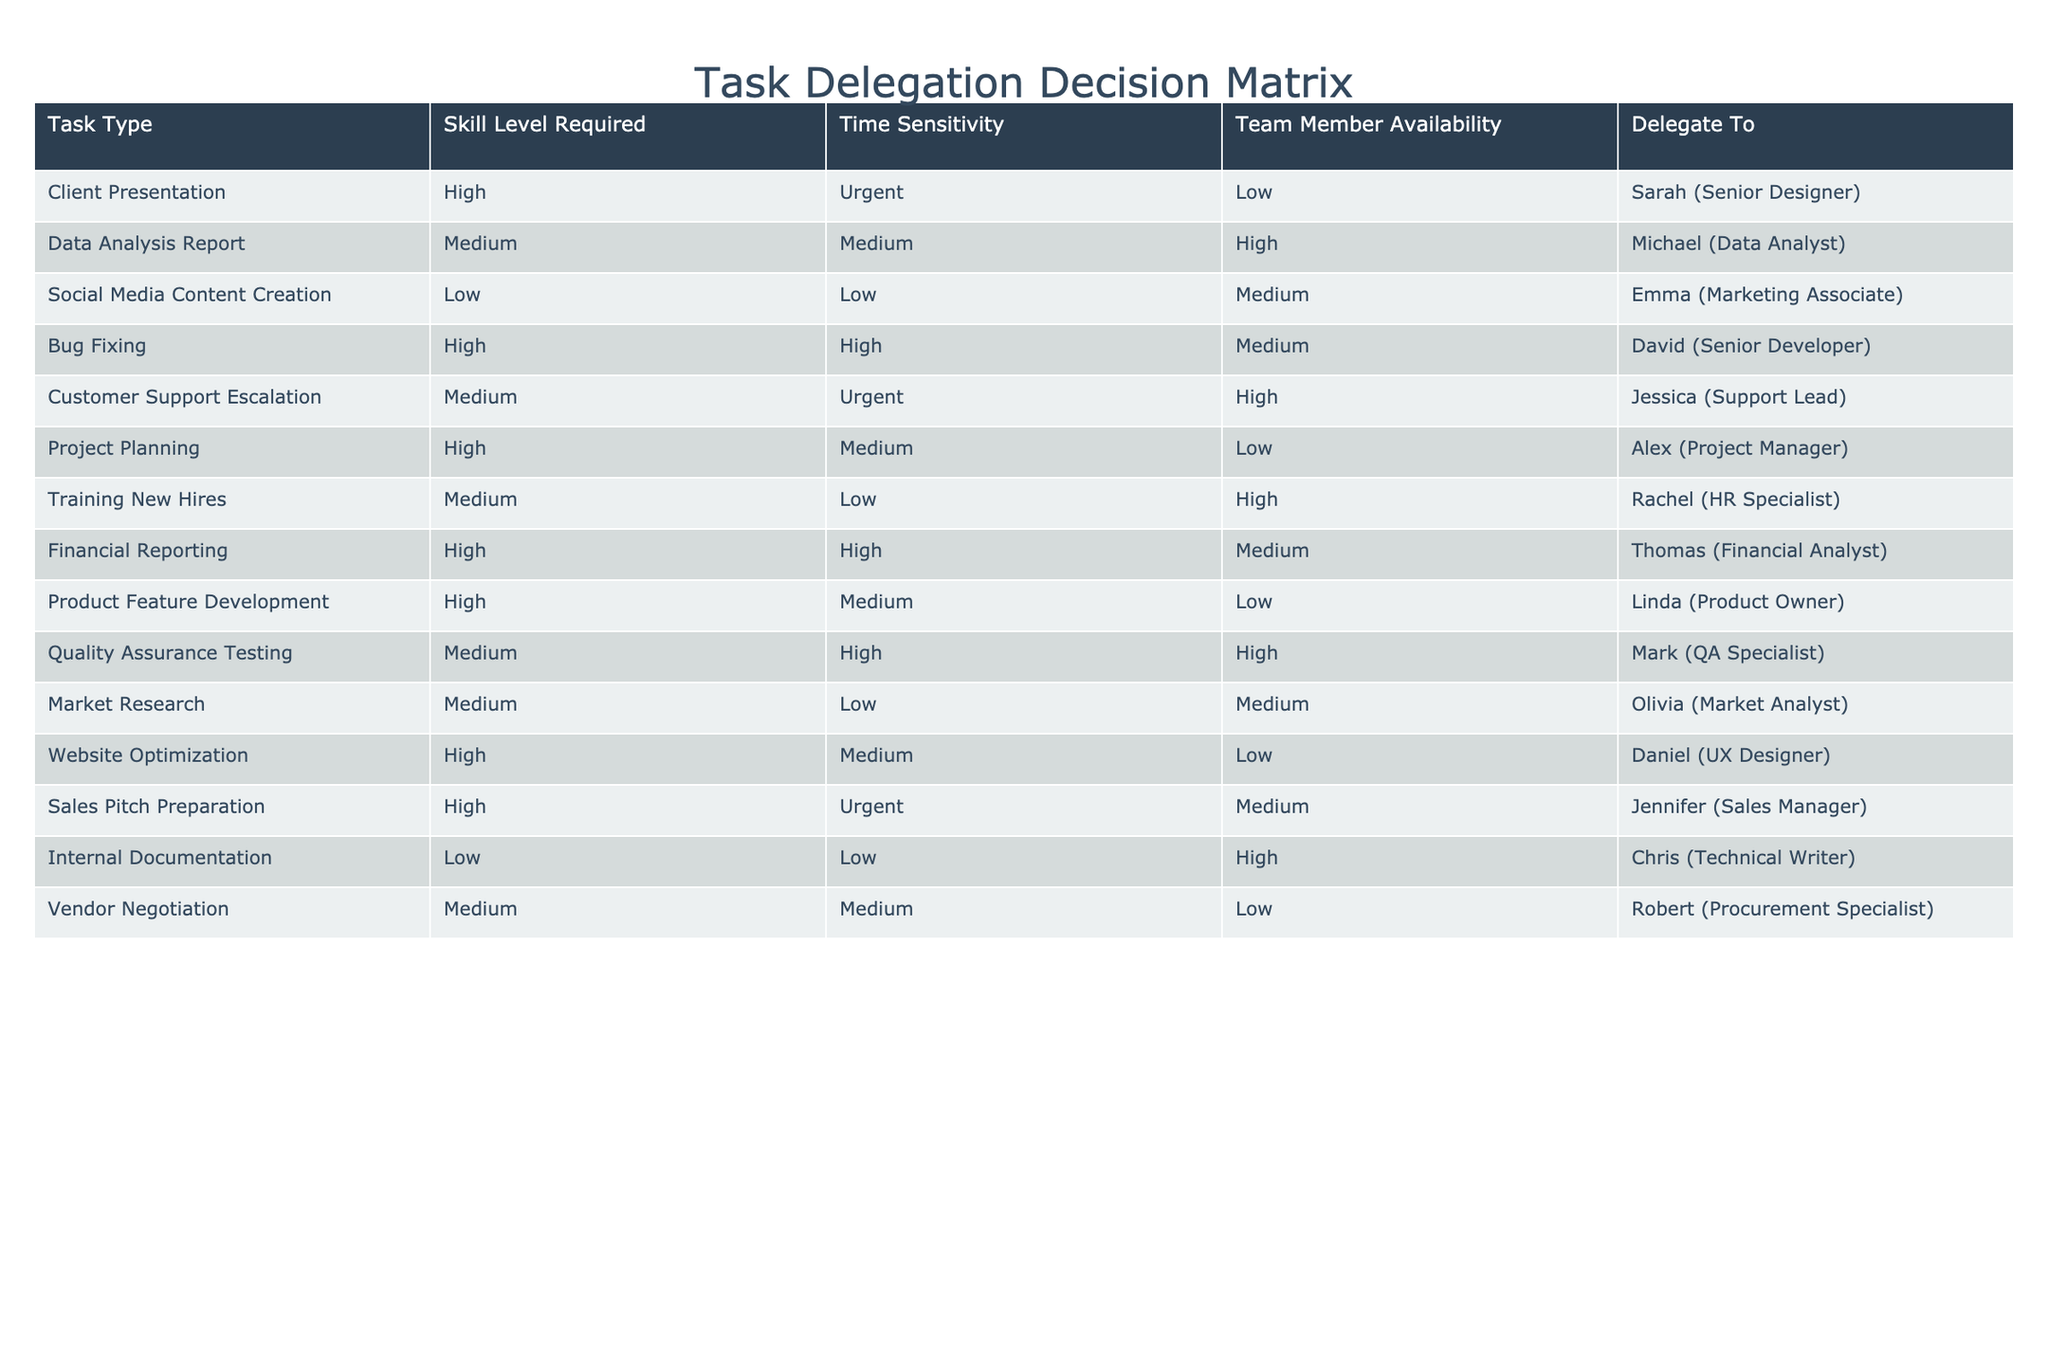What task is assigned to Sarah? The table shows that Sarah is assigned to the task "Client Presentation."
Answer: Client Presentation Which team member is tasked with "Customer Support Escalation"? From the table, Jessica is assigned to "Customer Support Escalation."
Answer: Jessica How many tasks require a high skill level? By counting the rows marked with "High" under the Skill Level Required column, we find there are 6 tasks requiring a high skill level.
Answer: 6 Are there any tasks assigned to team members with low availability? The table indicates that there are tasks assigned to team members with low availability; specifically, "Client Presentation," "Project Planning," and "Website Optimization" are assigned to team members with low availability.
Answer: Yes Who has the highest number of urgent tasks assigned to them? Examining the Urgent column, we find that both Sarah and Jessica have urgent tasks assigned to them, but Jessica has only one while Sarah has one as well—therefore, no single person stands out in this scenario.
Answer: None (tie) Which task has the lowest skill level requirement and is assigned to a member with high availability? The task "Social Media Content Creation" has a low skill level requirement and is assigned to Emma, who has medium availability. The question is asking about high availability, hence the answer is no tasks fit this criteria.
Answer: No tasks fit this criteria If we consider only the urgent tasks, how many team members are involved? The urgent tasks—"Client Presentation," "Bug Fixing," and "Customer Support Escalation"—involve 3 different team members: Sarah, David, and Jessica.
Answer: 3 What is the average skill level requirement of tasks assigned to team members with medium availability? The involved tasks for medium availability are "Data Analysis Report," "Customer Support Escalation," "Market Research," and "Quality Assurance Testing," which have skill levels of 2 (Medium), 2 (Medium), 1 (Low), and 2 (Medium). Adding them gives us 7, and dividing by 4 gives the average skill level of 1.75.
Answer: 1.75 Is there a task that requires both high skill level and high time sensitivity? Upon reviewing the table, "Bug Fixing" and "Financial Reporting" both meet the criteria, indicating there are tasks that require both high skill level and high time sensitivity.
Answer: Yes 